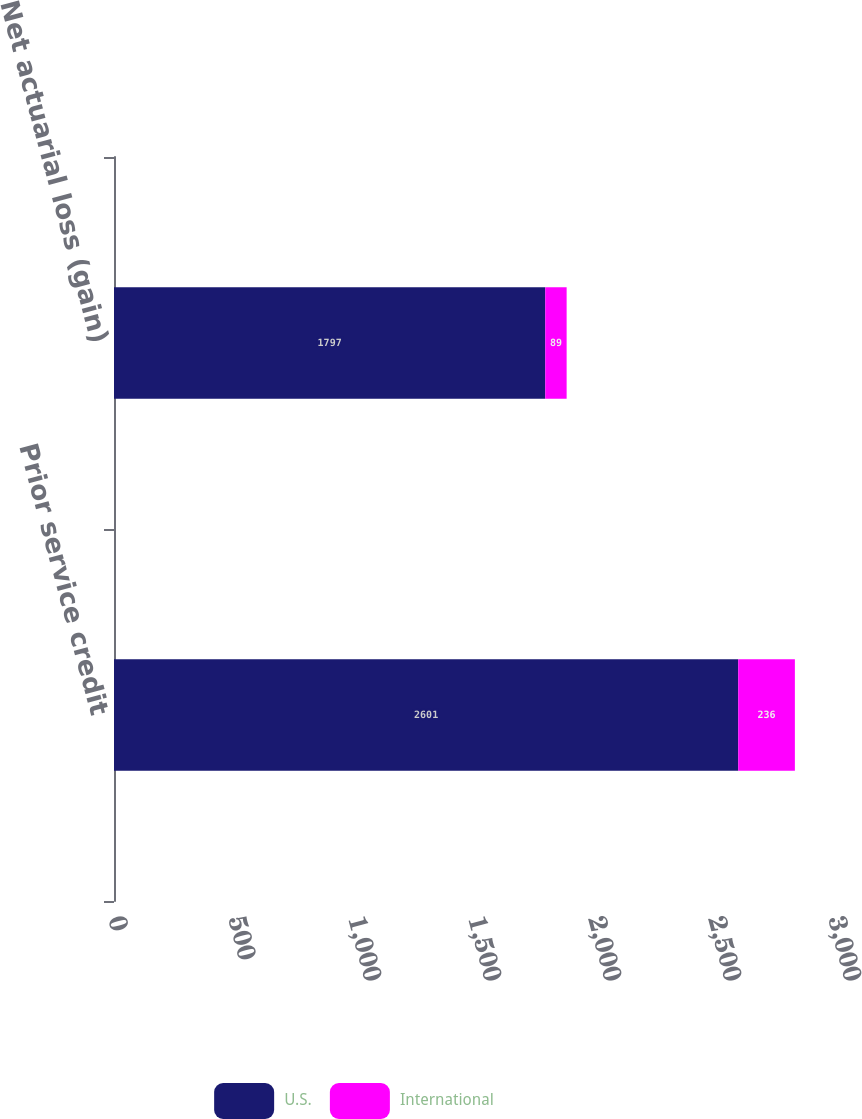<chart> <loc_0><loc_0><loc_500><loc_500><stacked_bar_chart><ecel><fcel>Prior service credit<fcel>Net actuarial loss (gain)<nl><fcel>U.S.<fcel>2601<fcel>1797<nl><fcel>International<fcel>236<fcel>89<nl></chart> 